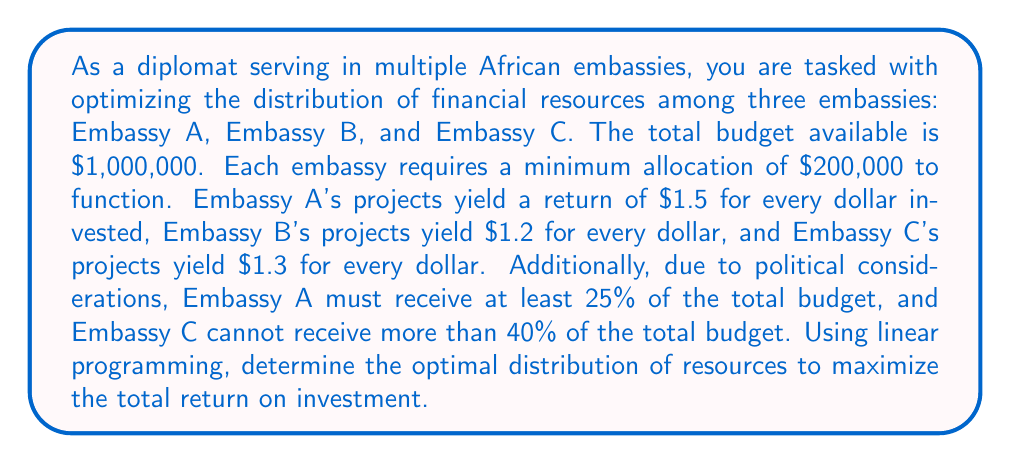Solve this math problem. Let's approach this problem using linear programming:

1) Define variables:
   Let $x_A$, $x_B$, and $x_C$ be the amounts allocated to Embassies A, B, and C respectively.

2) Objective function:
   Maximize $Z = 1.5x_A + 1.2x_B + 1.3x_C$

3) Constraints:
   a) Total budget: $x_A + x_B + x_C \leq 1,000,000$
   b) Minimum allocations: $x_A \geq 200,000$, $x_B \geq 200,000$, $x_C \geq 200,000$
   c) Embassy A's minimum share: $x_A \geq 0.25(1,000,000) = 250,000$
   d) Embassy C's maximum share: $x_C \leq 0.40(1,000,000) = 400,000$
   e) Non-negativity: $x_A, x_B, x_C \geq 0$

4) Solve using the simplex method or a linear programming solver.

The optimal solution is:
$x_A = 400,000$
$x_B = 200,000$
$x_C = 400,000$

5) Verify constraints:
   a) $400,000 + 200,000 + 400,000 = 1,000,000$ (satisfies total budget)
   b) All allocations ≥ $200,000 (satisfies minimum allocations)
   c) $400,000 > 250,000$ (satisfies Embassy A's minimum share)
   d) $400,000 \leq 400,000$ (satisfies Embassy C's maximum share)

6) Calculate maximum return:
   $Z = 1.5(400,000) + 1.2(200,000) + 1.3(400,000) = 1,360,000$

Therefore, the optimal distribution is to allocate $400,000 to Embassy A, $200,000 to Embassy B, and $400,000 to Embassy C, resulting in a total return of $1,360,000.
Answer: The optimal distribution is:
Embassy A: $400,000
Embassy B: $200,000
Embassy C: $400,000
Maximum return: $1,360,000 